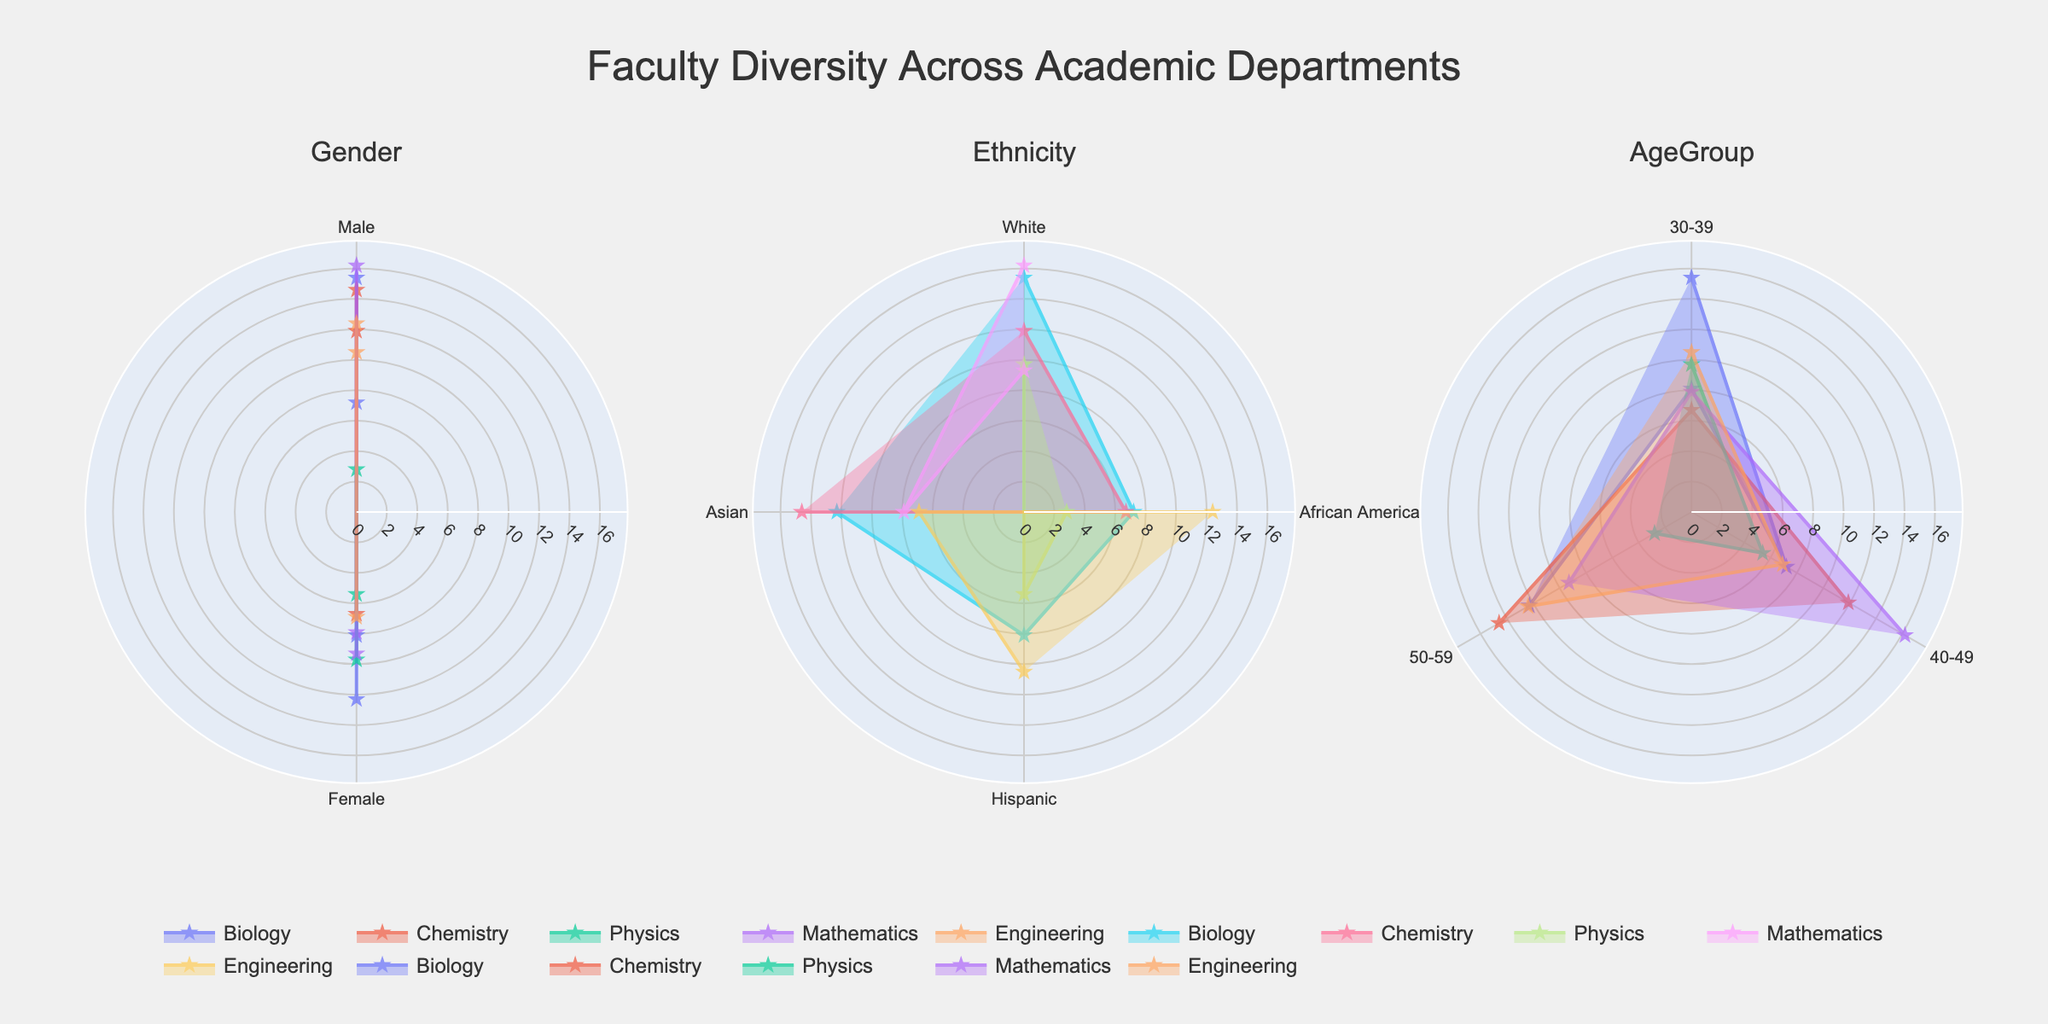What is the title of the figure? The title of the figure is usually displayed at the top center of the chart. In this case, the title is "Faculty Diversity Across Academic Departments".
Answer: Faculty Diversity Across Academic Departments Which academic department has the largest data point in the Gender subplot? By examining the radial lengths in the Gender subplot, the largest value is associated with the Mathematics department under 'Male', represented by 16.2%.
Answer: Mathematics What is the percentage of female Hispanic faculty members in the Biology department? The percentage can be found by looking at the specific slice labeled 'Female' and 'Hispanic' under the Biology department in the subplot depicting Ethnicity. It is shown as 8.1%.
Answer: 8.1% How does the percentage of male White faculty in Chemistry compare with female White faculty in Physics? By comparing the radial lengths for 'Male' and 'White' in Chemistry (11.9%) with 'Female' and 'White' in Physics (9.7%), Chemistry has a higher percentage.
Answer: Chemistry has a higher percentage What is the aggregated percentage of all Asian faculty members across all departments? Summing the percentages of Asian faculty members in the Ethnicity subplot: Biology (12.3%) + Chemistry (14.6%) + Mathematics (7.9%) + Engineering (6.9%) equals 41.7%.
Answer: 41.7% Are there any age groups that are missing representation in any department? To determine this, observe the AgeGroup subplot for missing segments. For instance, there is no representation for 50-59 age group in Physics and for 30-39 and 40-49 age groups in certain departments.
Answer: Yes What is the percentage difference between male faculty in the 50-59 age group in Chemistry and Engineering? Identifying the percentages from the AgeGroup subplot, Chemistry's male faculty in this group is 14.6%, and Engineering's is 12.4%. Thus, the difference is 14.6 - 12.4 = 2.2%.
Answer: 2.2% Which department has the smallest percentage of African American faculty, and what is the value? By examining the Ethnicity subplot, the Physics department has the smallest percentage of African American faculty, shown as 2.8%.
Answer: Physics, 2.8% What is the average percentage of female faculty members in the 30-39 age group across all departments? Summing the female percentages in the 30-39 age group: Biology (8.1%) + Chemistry (6.7%) + Physics (9.7%) + Mathematics (7.9%) and dividing by the number of departments (4) equals (8.1 + 6.7 + 9.7 + 7.9)/4 = 8.1%.
Answer: 8.1% Which gender has more variability in their percentages across Ethnic groups? By assessing the spread and variation of the radial lengths for each gender in the Ethnicity subplot, female faculty percentages show a broader range (5.4% to 12.3%) compared to male faculty.
Answer: Female 